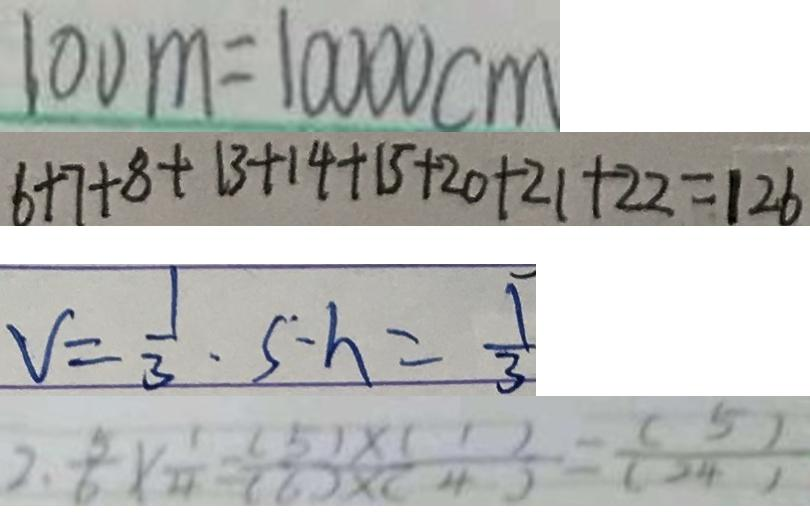<formula> <loc_0><loc_0><loc_500><loc_500>1 0 0 m = 1 0 0 0 0 c m 
 6 + 7 + 8 + 1 3 + 1 4 + 1 5 + 2 0 + 2 1 + 2 2 = 1 2 6 
 V = \frac { 1 } { 3 } \cdot S \cdot h = \frac { 1 } { 3 } 
 2 . \frac { 5 } { 6 } \times \frac { 1 } { 4 } = \frac { ( 5 ) \times ( 1 ) } { ( 6 ) \times ( 4 ) } = \frac { ( 5 ) } { ( 2 4 ) }</formula> 